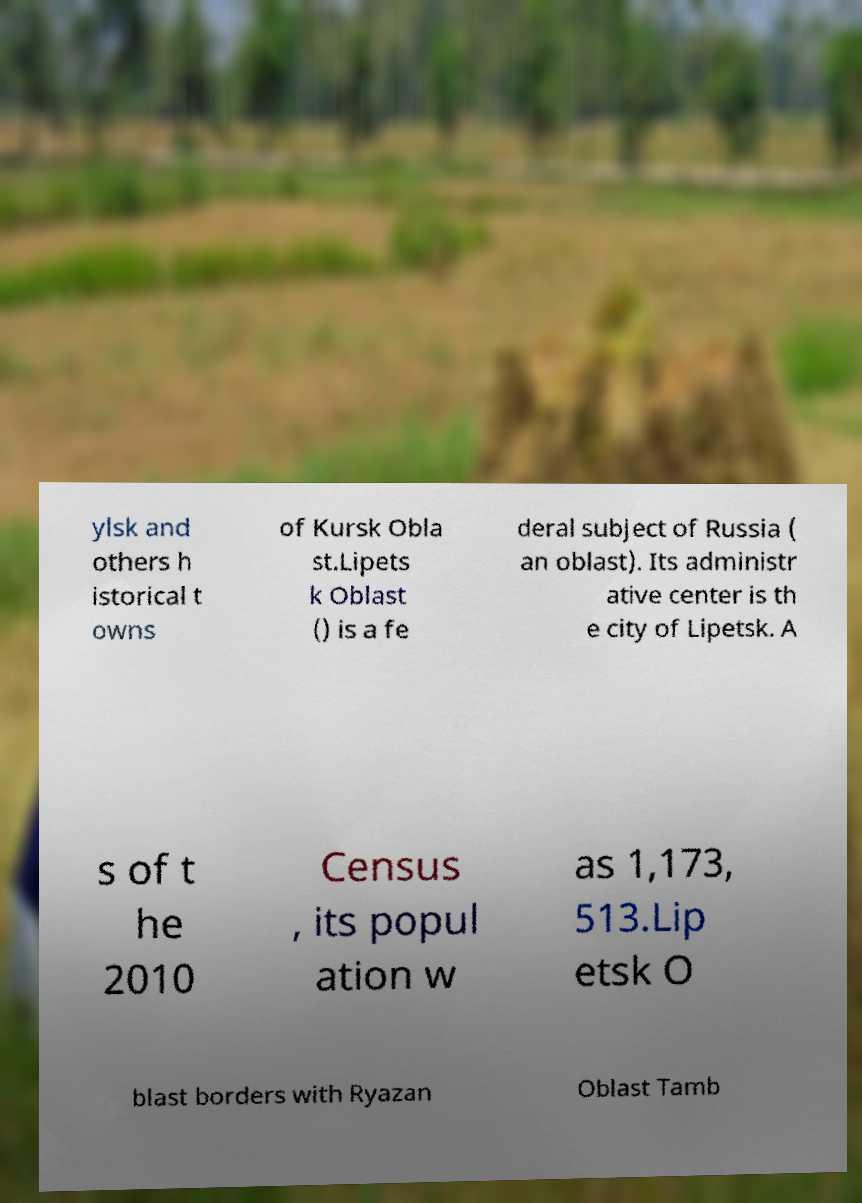What messages or text are displayed in this image? I need them in a readable, typed format. ylsk and others h istorical t owns of Kursk Obla st.Lipets k Oblast () is a fe deral subject of Russia ( an oblast). Its administr ative center is th e city of Lipetsk. A s of t he 2010 Census , its popul ation w as 1,173, 513.Lip etsk O blast borders with Ryazan Oblast Tamb 